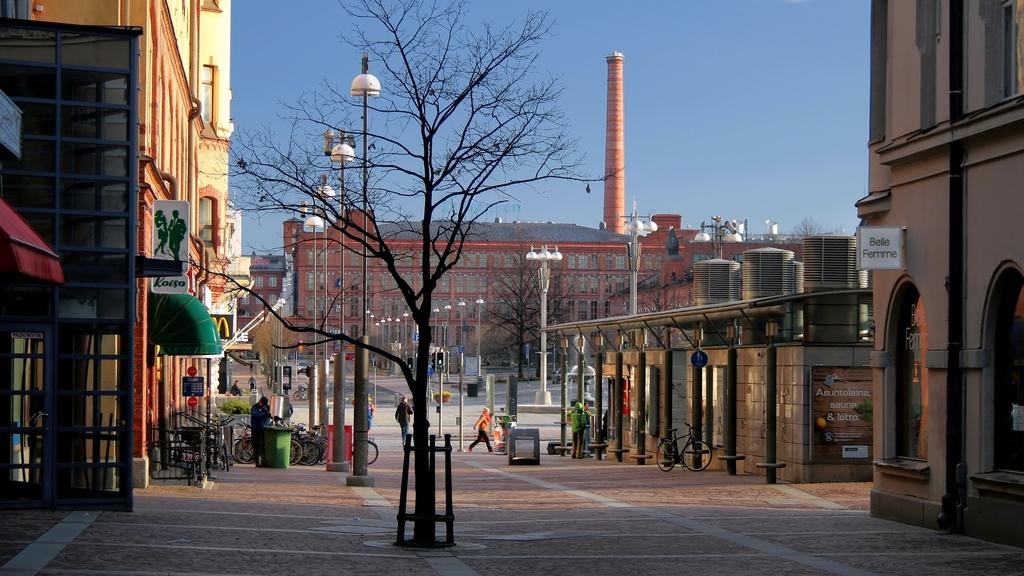What are the people in the image doing? The people in the image are standing on the ground. What can be seen on the road in the image? There are street light poles on the road. What structures are visible in the background of the image? There are buildings visible in the image. What mode of transportation can be seen in the image? There are bicycles present in the image. What type of pancake is being served at the restaurant in the image? There is no restaurant or pancake present in the image. Can you describe the veil worn by the person in the image? There is no veil or person wearing a veil present in the image. 